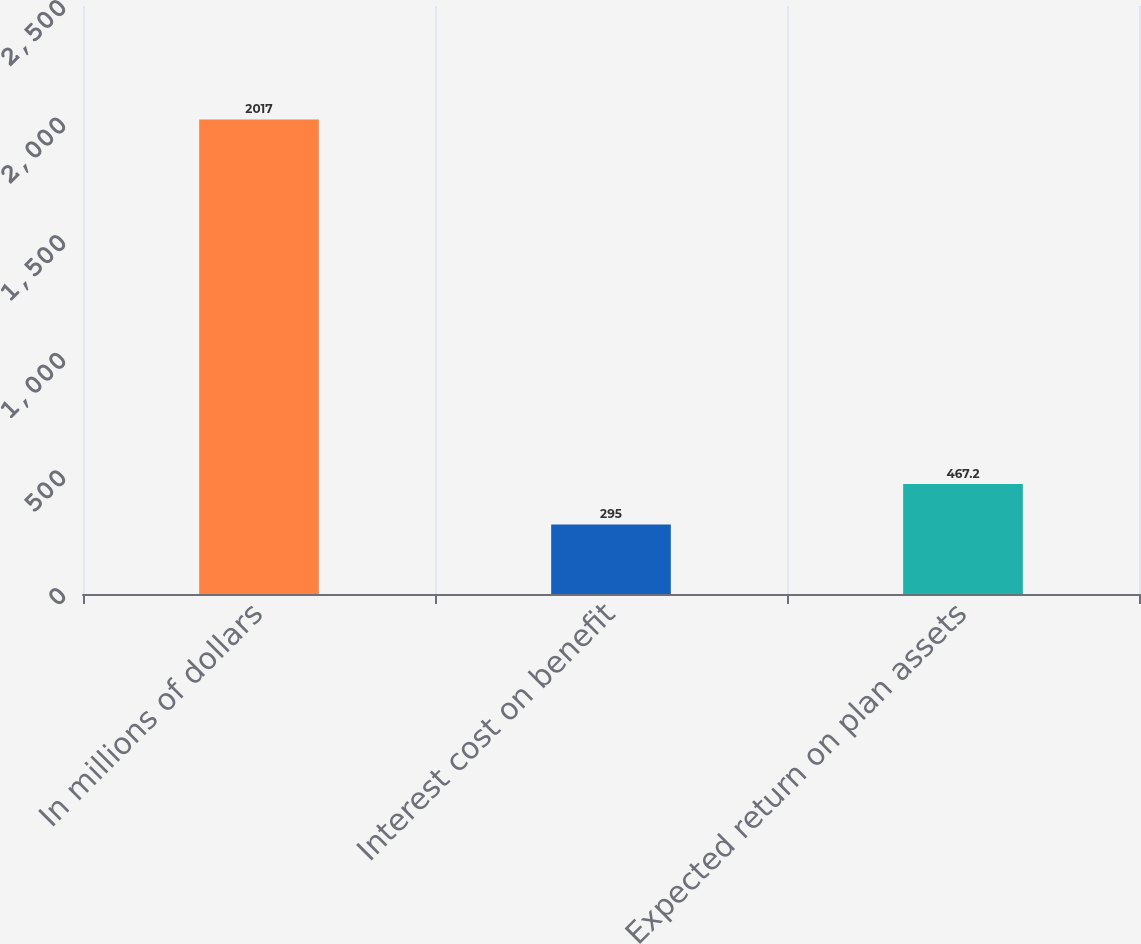Convert chart. <chart><loc_0><loc_0><loc_500><loc_500><bar_chart><fcel>In millions of dollars<fcel>Interest cost on benefit<fcel>Expected return on plan assets<nl><fcel>2017<fcel>295<fcel>467.2<nl></chart> 